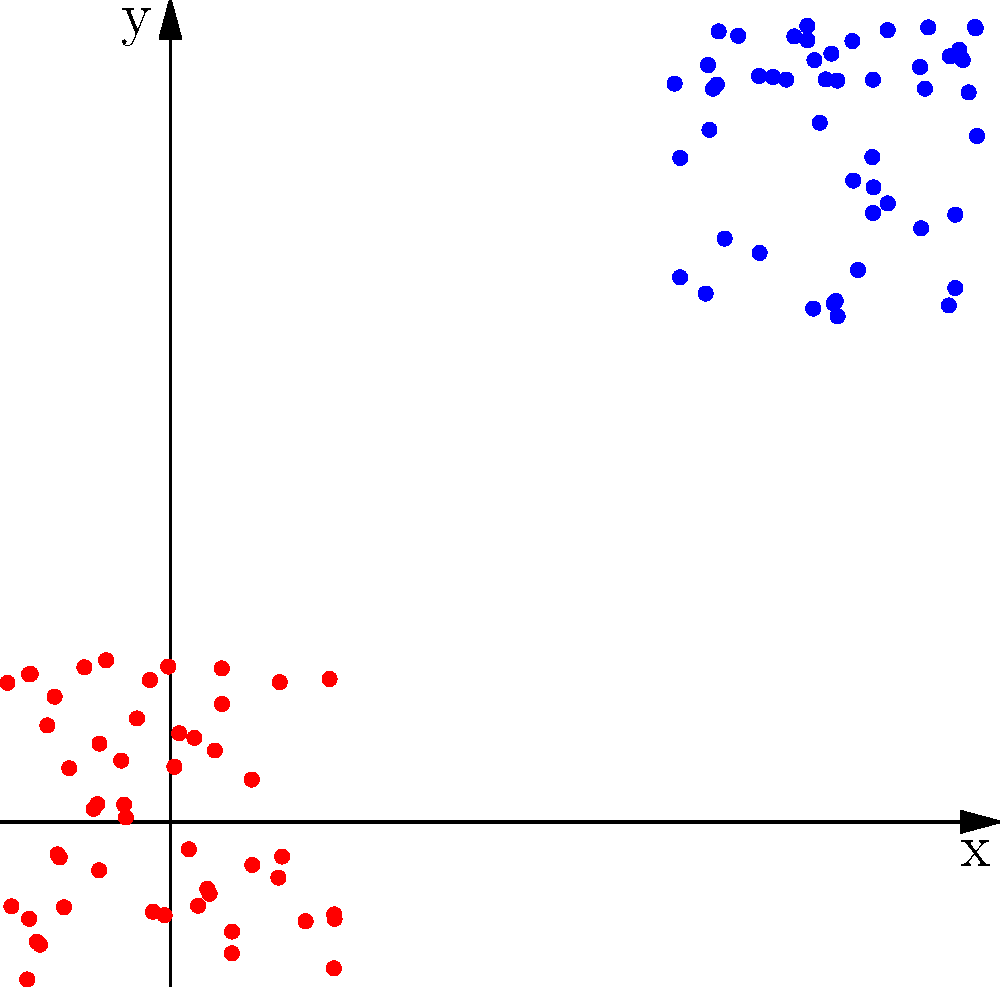As an open-source privacy tool developer, you're analyzing a scatter plot of encrypted data points. The plot shows two distinct clusters of points, one in red and one in blue. What encryption technique is likely being used, and what potential privacy implications does this clustering suggest? To answer this question, let's analyze the scatter plot step-by-step:

1. Observation: The plot shows two distinct clusters of points, one in red and one in blue.

2. Clustering in encrypted data: The presence of clear clusters in encrypted data is unusual and suggests that the encryption method used is not fully secure.

3. Likely encryption technique: This pattern is characteristic of deterministic encryption. In deterministic encryption, the same plaintext always encrypts to the same ciphertext.

4. How deterministic encryption works:
   - Each data point represents an encrypted value.
   - Similar or identical original values encrypt to similar or identical encrypted values.
   - This preserves some patterns from the original data.

5. Privacy implications:
   - Attackers can infer relationships between data points without decrypting them.
   - They can potentially guess the nature of the data based on the clustering.
   - In some cases, they might even be able to approximate original values.

6. Better alternatives:
   - Probabilistic encryption would produce a more uniform distribution of points.
   - Homomorphic encryption would allow computations on encrypted data without revealing patterns.

7. Importance for open-source privacy tools:
   - As a developer of privacy tools, it's crucial to understand these vulnerabilities.
   - This knowledge can be used to improve encryption methods in open-source projects.
   - It emphasizes the need for rigorous testing of encryption techniques.

In conclusion, the clustering suggests the use of deterministic encryption, which has significant privacy implications due to the preservation of patterns in the encrypted data.
Answer: Deterministic encryption; allows inference of data relationships without decryption. 